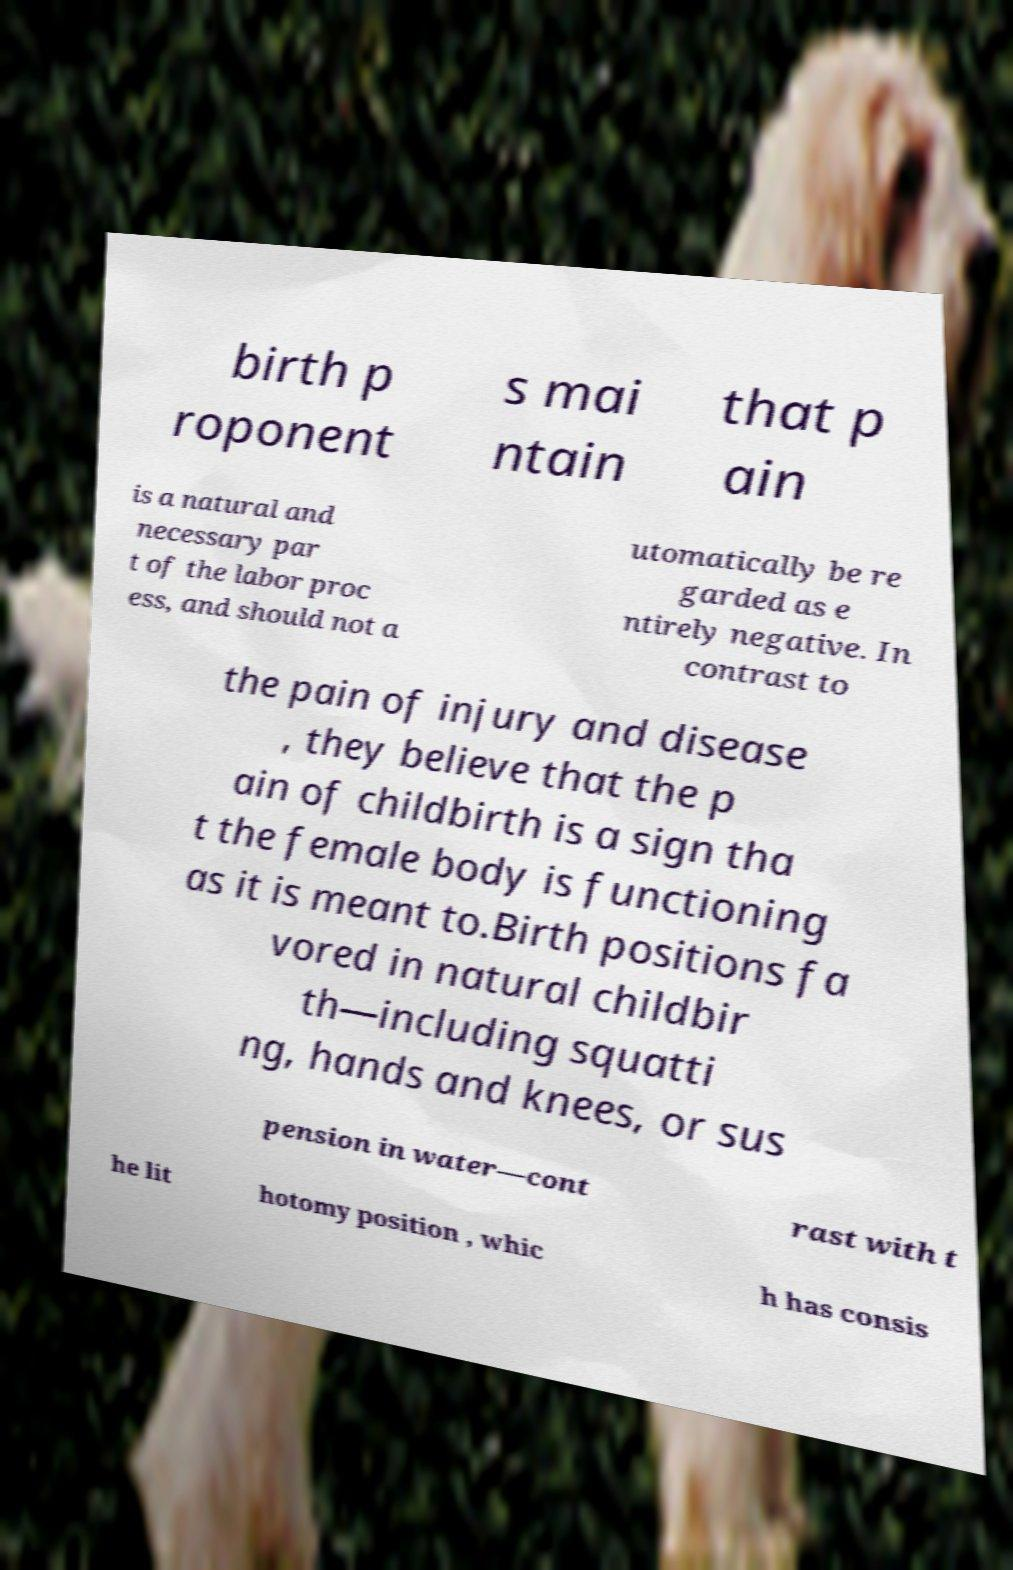I need the written content from this picture converted into text. Can you do that? birth p roponent s mai ntain that p ain is a natural and necessary par t of the labor proc ess, and should not a utomatically be re garded as e ntirely negative. In contrast to the pain of injury and disease , they believe that the p ain of childbirth is a sign tha t the female body is functioning as it is meant to.Birth positions fa vored in natural childbir th—including squatti ng, hands and knees, or sus pension in water—cont rast with t he lit hotomy position , whic h has consis 